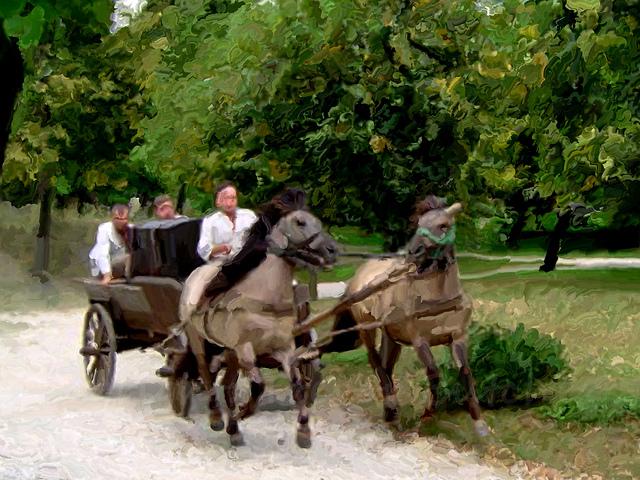How many horse(s) are pulling the carriage?
Quick response, please. 2. How much horsepower in this vehicle?
Give a very brief answer. 2. How many horses are present?
Write a very short answer. 2. Does the guy have a hat on?
Keep it brief. No. Is this an old-fashioned horse carriage?
Answer briefly. Yes. How many men are in the trailer?
Be succinct. 3. How many people are in the carriage?
Give a very brief answer. 3. 